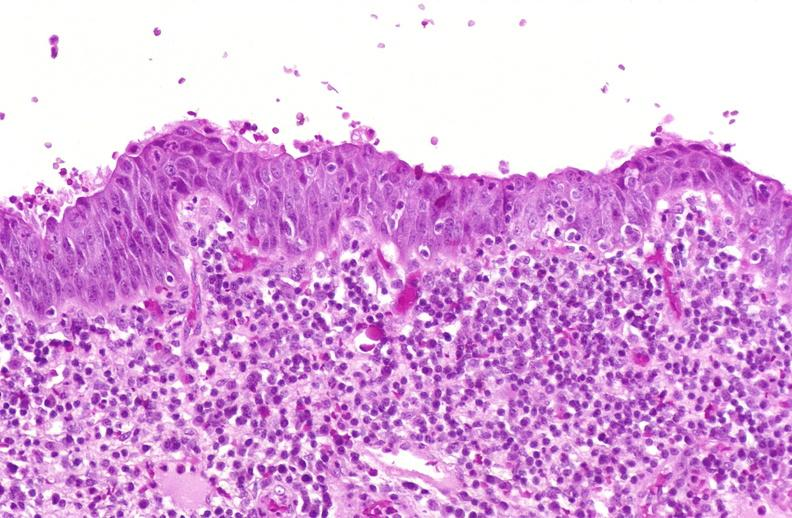why does this image show squamous metaplasia, renal pelvis?
Answer the question using a single word or phrase. Due to nephrolithiasis 